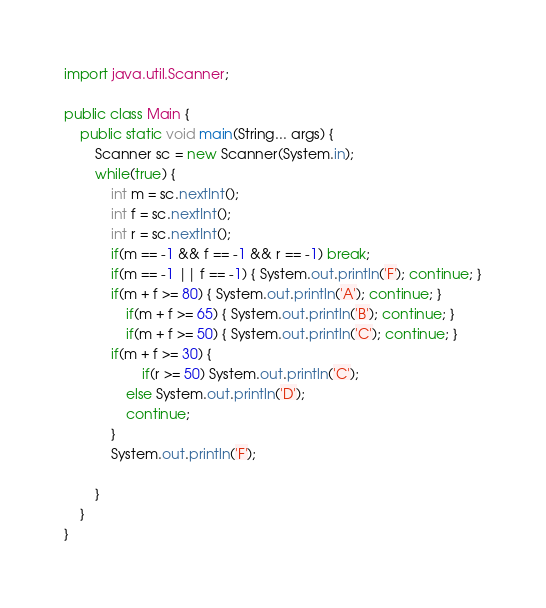Convert code to text. <code><loc_0><loc_0><loc_500><loc_500><_Java_>import java.util.Scanner;
 
public class Main {
    public static void main(String... args) {
        Scanner sc = new Scanner(System.in);
        while(true) {
            int m = sc.nextInt();
            int f = sc.nextInt();
            int r = sc.nextInt();
            if(m == -1 && f == -1 && r == -1) break;
            if(m == -1 || f == -1) { System.out.println('F'); continue; }
            if(m + f >= 80) { System.out.println('A'); continue; }
                if(m + f >= 65) { System.out.println('B'); continue; }
                if(m + f >= 50) { System.out.println('C'); continue; }
            if(m + f >= 30) {
                    if(r >= 50) System.out.println('C');
                else System.out.println('D');
                continue;
            }
            System.out.println('F');
             
        }
    }
}
</code> 